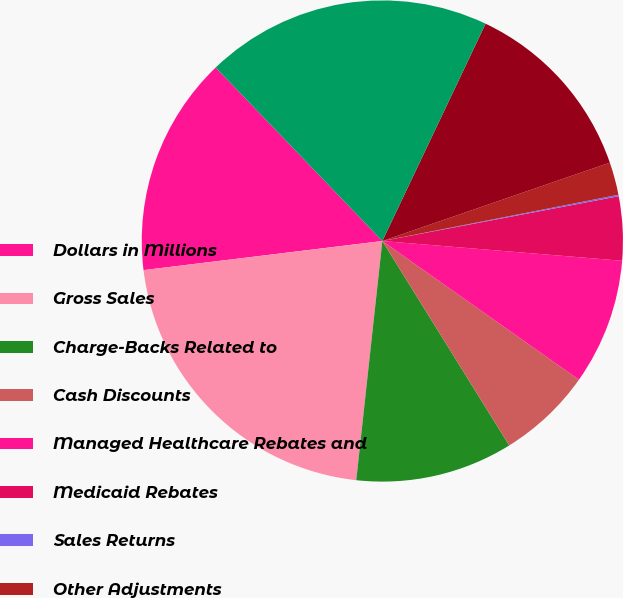Convert chart. <chart><loc_0><loc_0><loc_500><loc_500><pie_chart><fcel>Dollars in Millions<fcel>Gross Sales<fcel>Charge-Backs Related to<fcel>Cash Discounts<fcel>Managed Healthcare Rebates and<fcel>Medicaid Rebates<fcel>Sales Returns<fcel>Other Adjustments<fcel>Total Gross-to-Net Sales<fcel>Net Sales<nl><fcel>14.75%<fcel>21.34%<fcel>10.57%<fcel>6.38%<fcel>8.47%<fcel>4.29%<fcel>0.1%<fcel>2.2%<fcel>12.66%<fcel>19.24%<nl></chart> 